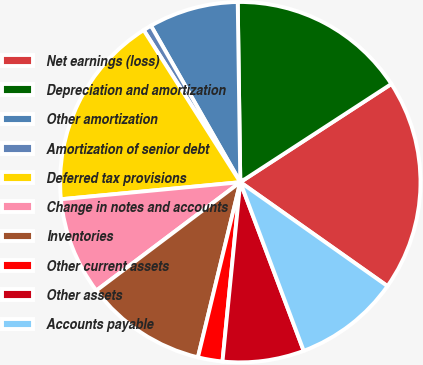<chart> <loc_0><loc_0><loc_500><loc_500><pie_chart><fcel>Net earnings (loss)<fcel>Depreciation and amortization<fcel>Other amortization<fcel>Amortization of senior debt<fcel>Deferred tax provisions<fcel>Change in notes and accounts<fcel>Inventories<fcel>Other current assets<fcel>Other assets<fcel>Accounts payable<nl><fcel>18.96%<fcel>16.05%<fcel>8.03%<fcel>0.75%<fcel>17.5%<fcel>8.76%<fcel>10.95%<fcel>2.2%<fcel>7.3%<fcel>9.49%<nl></chart> 